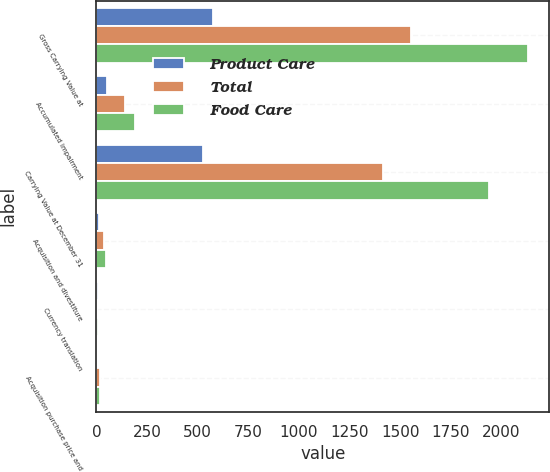Convert chart to OTSL. <chart><loc_0><loc_0><loc_500><loc_500><stacked_bar_chart><ecel><fcel>Gross Carrying Value at<fcel>Accumulated impairment<fcel>Carrying Value at December 31<fcel>Acquisition and divestiture<fcel>Currency translation<fcel>Acquisition purchase price and<nl><fcel>Product Care<fcel>576.5<fcel>49.5<fcel>526.9<fcel>10.1<fcel>6<fcel>0.6<nl><fcel>Total<fcel>1554.1<fcel>140.9<fcel>1412.9<fcel>39.3<fcel>1.5<fcel>18.2<nl><fcel>Food Care<fcel>2130.6<fcel>190.4<fcel>1939.8<fcel>49.4<fcel>7.5<fcel>17.6<nl></chart> 